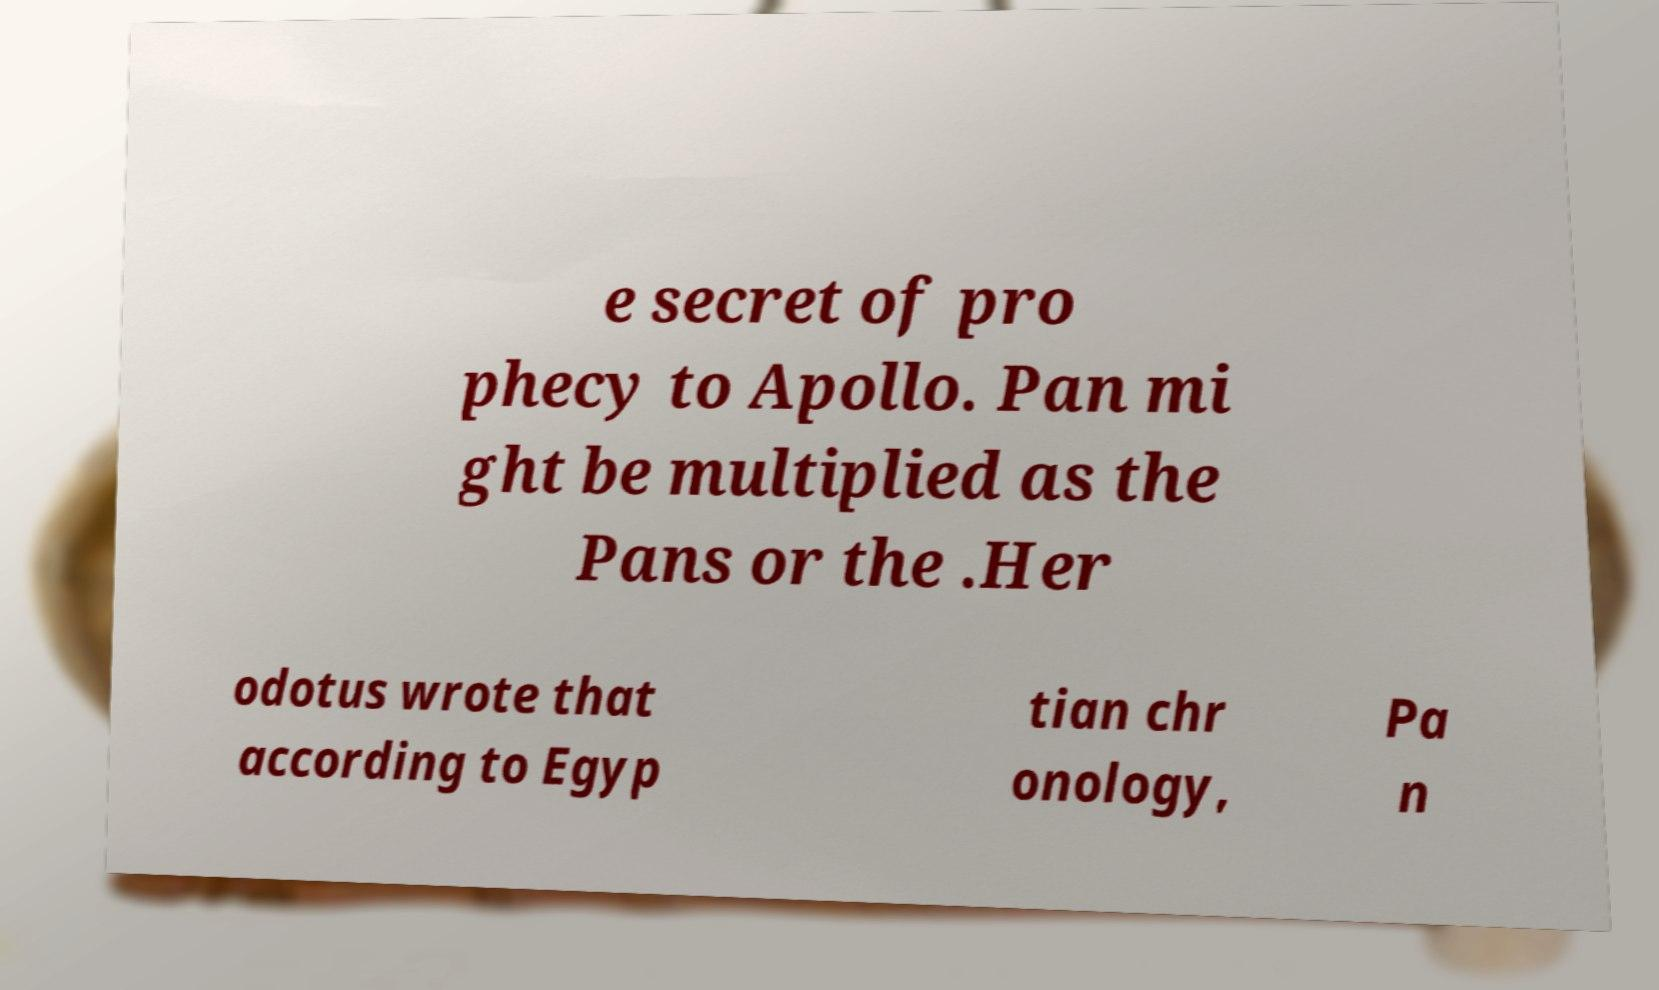Could you extract and type out the text from this image? e secret of pro phecy to Apollo. Pan mi ght be multiplied as the Pans or the .Her odotus wrote that according to Egyp tian chr onology, Pa n 